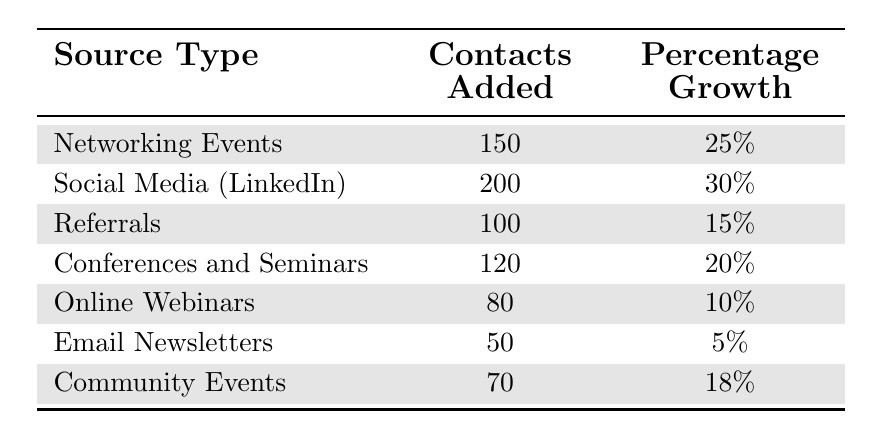What source type added the most contacts? The table shows the number of contacts added for each source type. Upon reviewing, Social Media (LinkedIn) has 200 contacts added, which is the highest value in the table.
Answer: Social Media (LinkedIn) What is the total number of contacts added across all sources? To find the total, we sum the contacts added: 150 + 200 + 100 + 120 + 80 + 50 + 70 = 870.
Answer: 870 Which source type had the lowest percentage growth? Looking at the percentage growth column, Email Newsletters has the lowest percentage growth at 5%.
Answer: Email Newsletters Is there a source type that added more than 100 contacts with a percentage growth of 20% or more? We check the table for source types with both criteria. Networking Events (150 contacts, 25% growth) and Social Media (LinkedIn) (200 contacts, 30% growth) both meet these criteria. Therefore, there are such source types.
Answer: Yes What is the average percentage growth of all the source types? To calculate the average percentage growth, we sum the percentage growth: 25 + 30 + 15 + 20 + 10 + 5 + 18 = 123, then divide by the number of sources (7): 123/7 ≈ 17.57%.
Answer: Approximately 17.57% How many more contacts were added through Networking Events compared to Online Webinars? We subtract the contacts added through Online Webinars (80) from Networking Events (150): 150 - 80 = 70.
Answer: 70 Can we say that more than half of the contacts added came from Social Media (LinkedIn)? Social Media (LinkedIn) added 200 contacts. Half of the total contacts is 870/2 = 435, which is greater than 200. Thus, more than half did not come from this source type.
Answer: No Which source contributed to the least absolute growth in terms of contacts added? From the contacts added, Email Newsletters contributed the least with 50 contacts.
Answer: Email Newsletters If we categorize sources by their growth percentage, how many sources had a growth percentage of 15% or more? Five sources have a percentage growth of 15% or more: Networking Events (25%), Social Media (LinkedIn) (30%), Conferences and Seminars (20%), Community Events (18%), and Referrals (15%). This means four sources meet the criteria.
Answer: Five sources What is the difference in contacts added between Conferences and Seminars and Community Events? We determine the difference by subtracting the contacts added by Community Events (70) from Conferences and Seminars (120): 120 - 70 = 50.
Answer: 50 